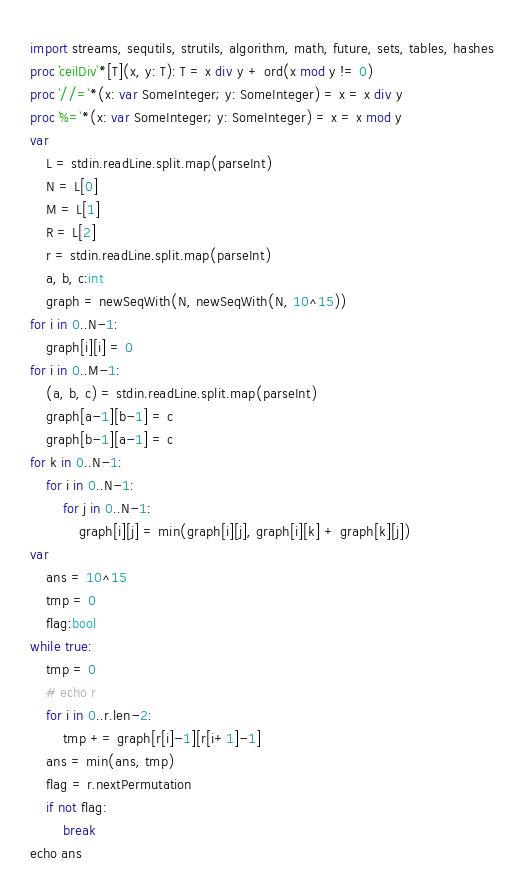<code> <loc_0><loc_0><loc_500><loc_500><_Nim_>import streams, sequtils, strutils, algorithm, math, future, sets, tables, hashes
proc `ceilDiv`*[T](x, y: T): T = x div y + ord(x mod y != 0)
proc `//=`*(x: var SomeInteger; y: SomeInteger) = x = x div y
proc `%=`*(x: var SomeInteger; y: SomeInteger) = x = x mod y
var
    L = stdin.readLine.split.map(parseInt)
    N = L[0]
    M = L[1]
    R = L[2]
    r = stdin.readLine.split.map(parseInt)
    a, b, c:int
    graph = newSeqWith(N, newSeqWith(N, 10^15))
for i in 0..N-1:
    graph[i][i] = 0
for i in 0..M-1:
    (a, b, c) = stdin.readLine.split.map(parseInt)
    graph[a-1][b-1] = c
    graph[b-1][a-1] = c
for k in 0..N-1:
    for i in 0..N-1:
        for j in 0..N-1:
            graph[i][j] = min(graph[i][j], graph[i][k] + graph[k][j])
var 
    ans = 10^15
    tmp = 0
    flag:bool
while true:
    tmp = 0
    # echo r
    for i in 0..r.len-2:
        tmp += graph[r[i]-1][r[i+1]-1]
    ans = min(ans, tmp)
    flag = r.nextPermutation
    if not flag:
        break
echo ans
</code> 